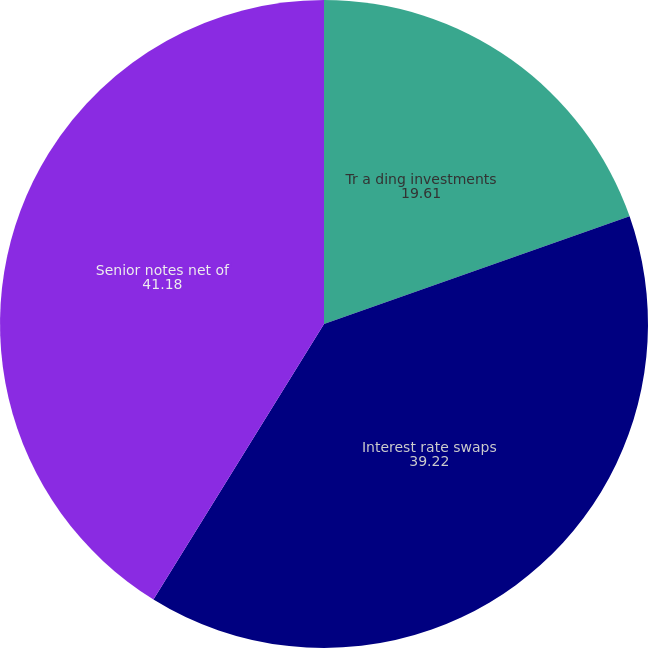Convert chart to OTSL. <chart><loc_0><loc_0><loc_500><loc_500><pie_chart><fcel>Tr a ding investments<fcel>Interest rate swaps<fcel>Senior notes net of<nl><fcel>19.61%<fcel>39.22%<fcel>41.18%<nl></chart> 